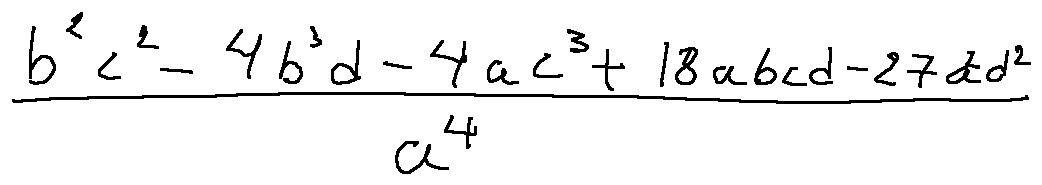<formula> <loc_0><loc_0><loc_500><loc_500>\frac { b ^ { 2 } c ^ { 2 } - 4 b ^ { 3 } d - 4 a c ^ { 3 } + 1 8 a b c d - 2 7 a ^ { 2 } d ^ { 2 } } { a ^ { 4 } }</formula> 